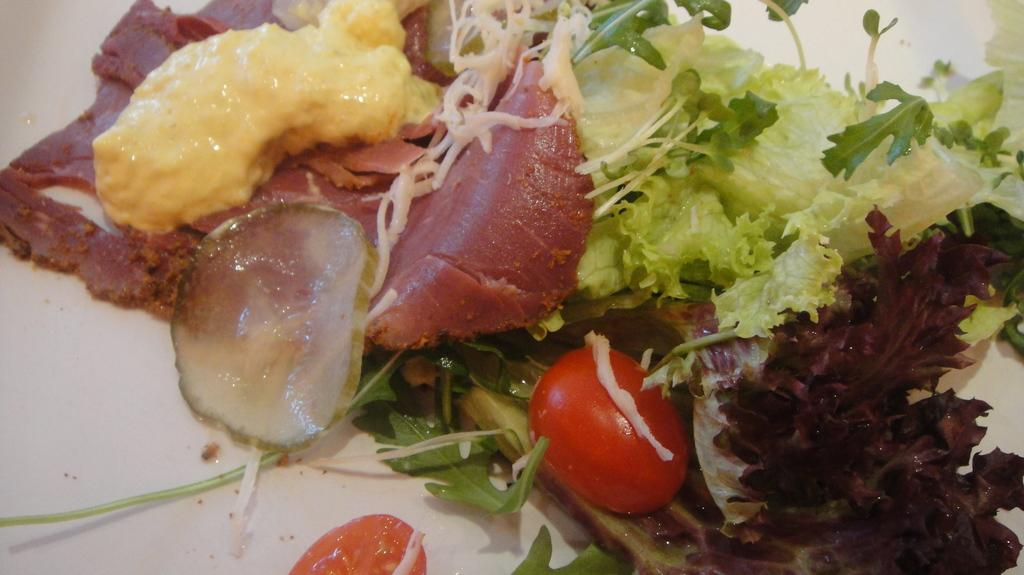What type of food items can be seen in the image? There are vegetables and meat in the image. What is the yellow substance in the image? There is a yellow paste in the image. What type of suit is being worn by the vegetable in the image? There are no people or clothing items present in the image, so it is not possible to determine if a vegetable is wearing a suit. 